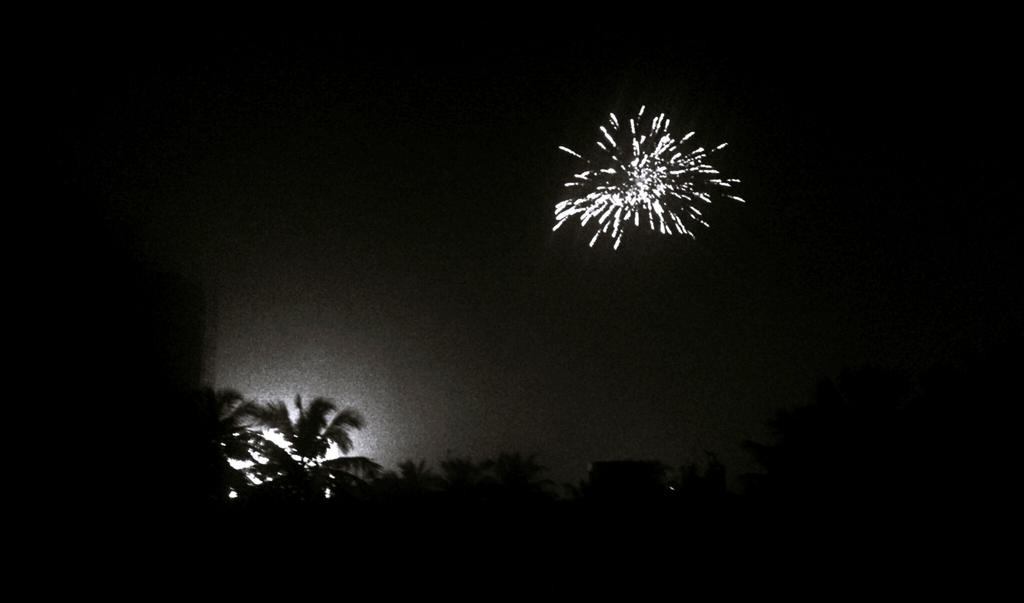What is the color scheme of the image? The image is black and white. What type of natural elements can be seen in the image? There are trees in the image. What additional feature is present in the image? Fireworks are present in the image. What part of the natural environment is visible in the image? The sky is visible in the image. Where are the children playing in the image? There are no children present in the image; it features trees, fireworks, and a black and white color scheme. What type of angle is the queen sitting at in the image? There is no queen present in the image; it features trees, fireworks, and a black and white color scheme. 